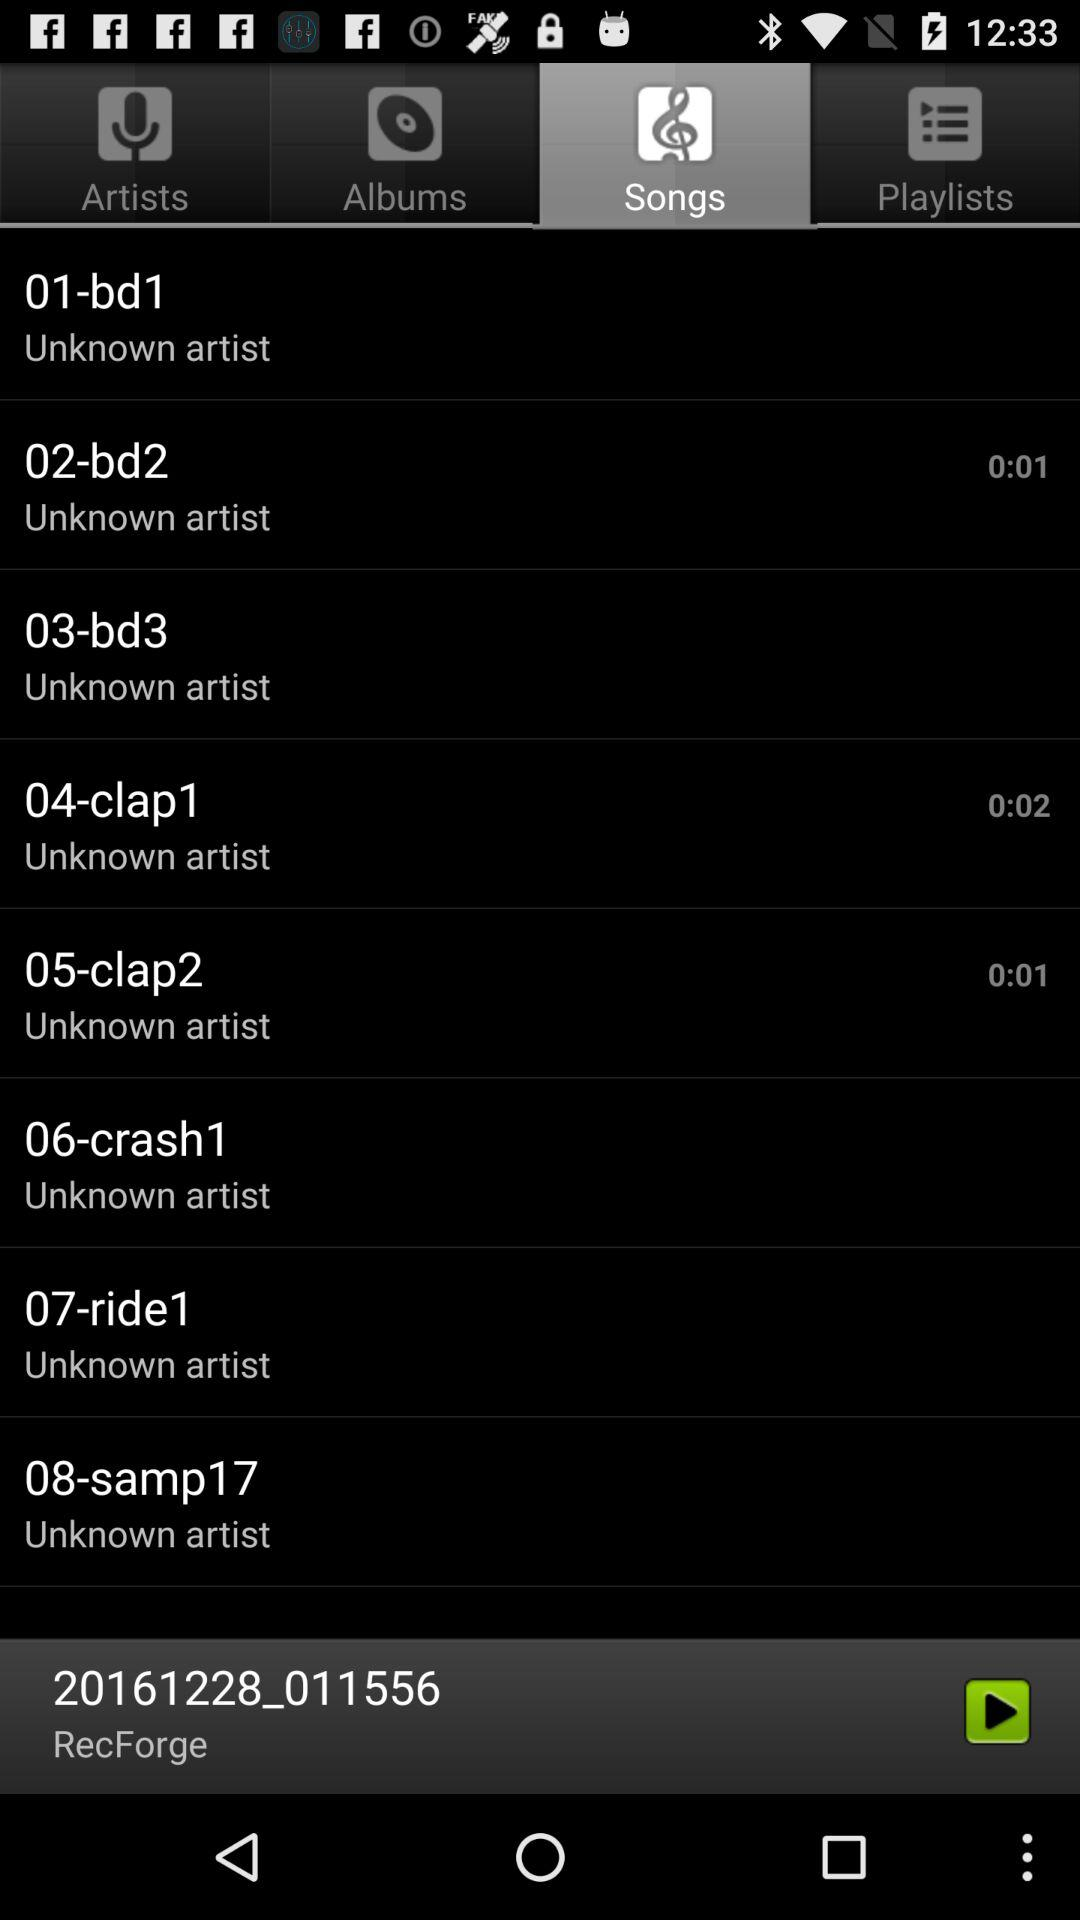What is the duration of the song "02-bd2"? The duration is 1 second. 